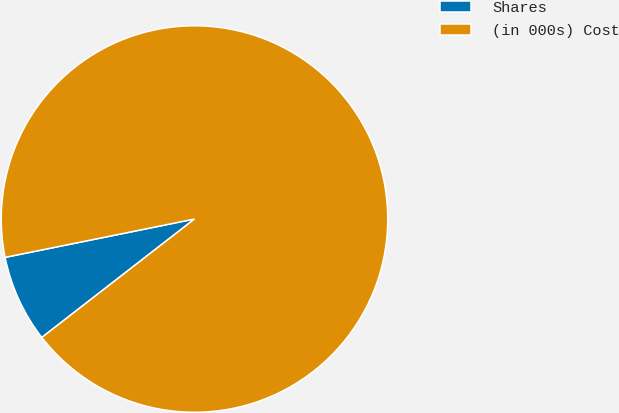<chart> <loc_0><loc_0><loc_500><loc_500><pie_chart><fcel>Shares<fcel>(in 000s) Cost<nl><fcel>7.32%<fcel>92.68%<nl></chart> 